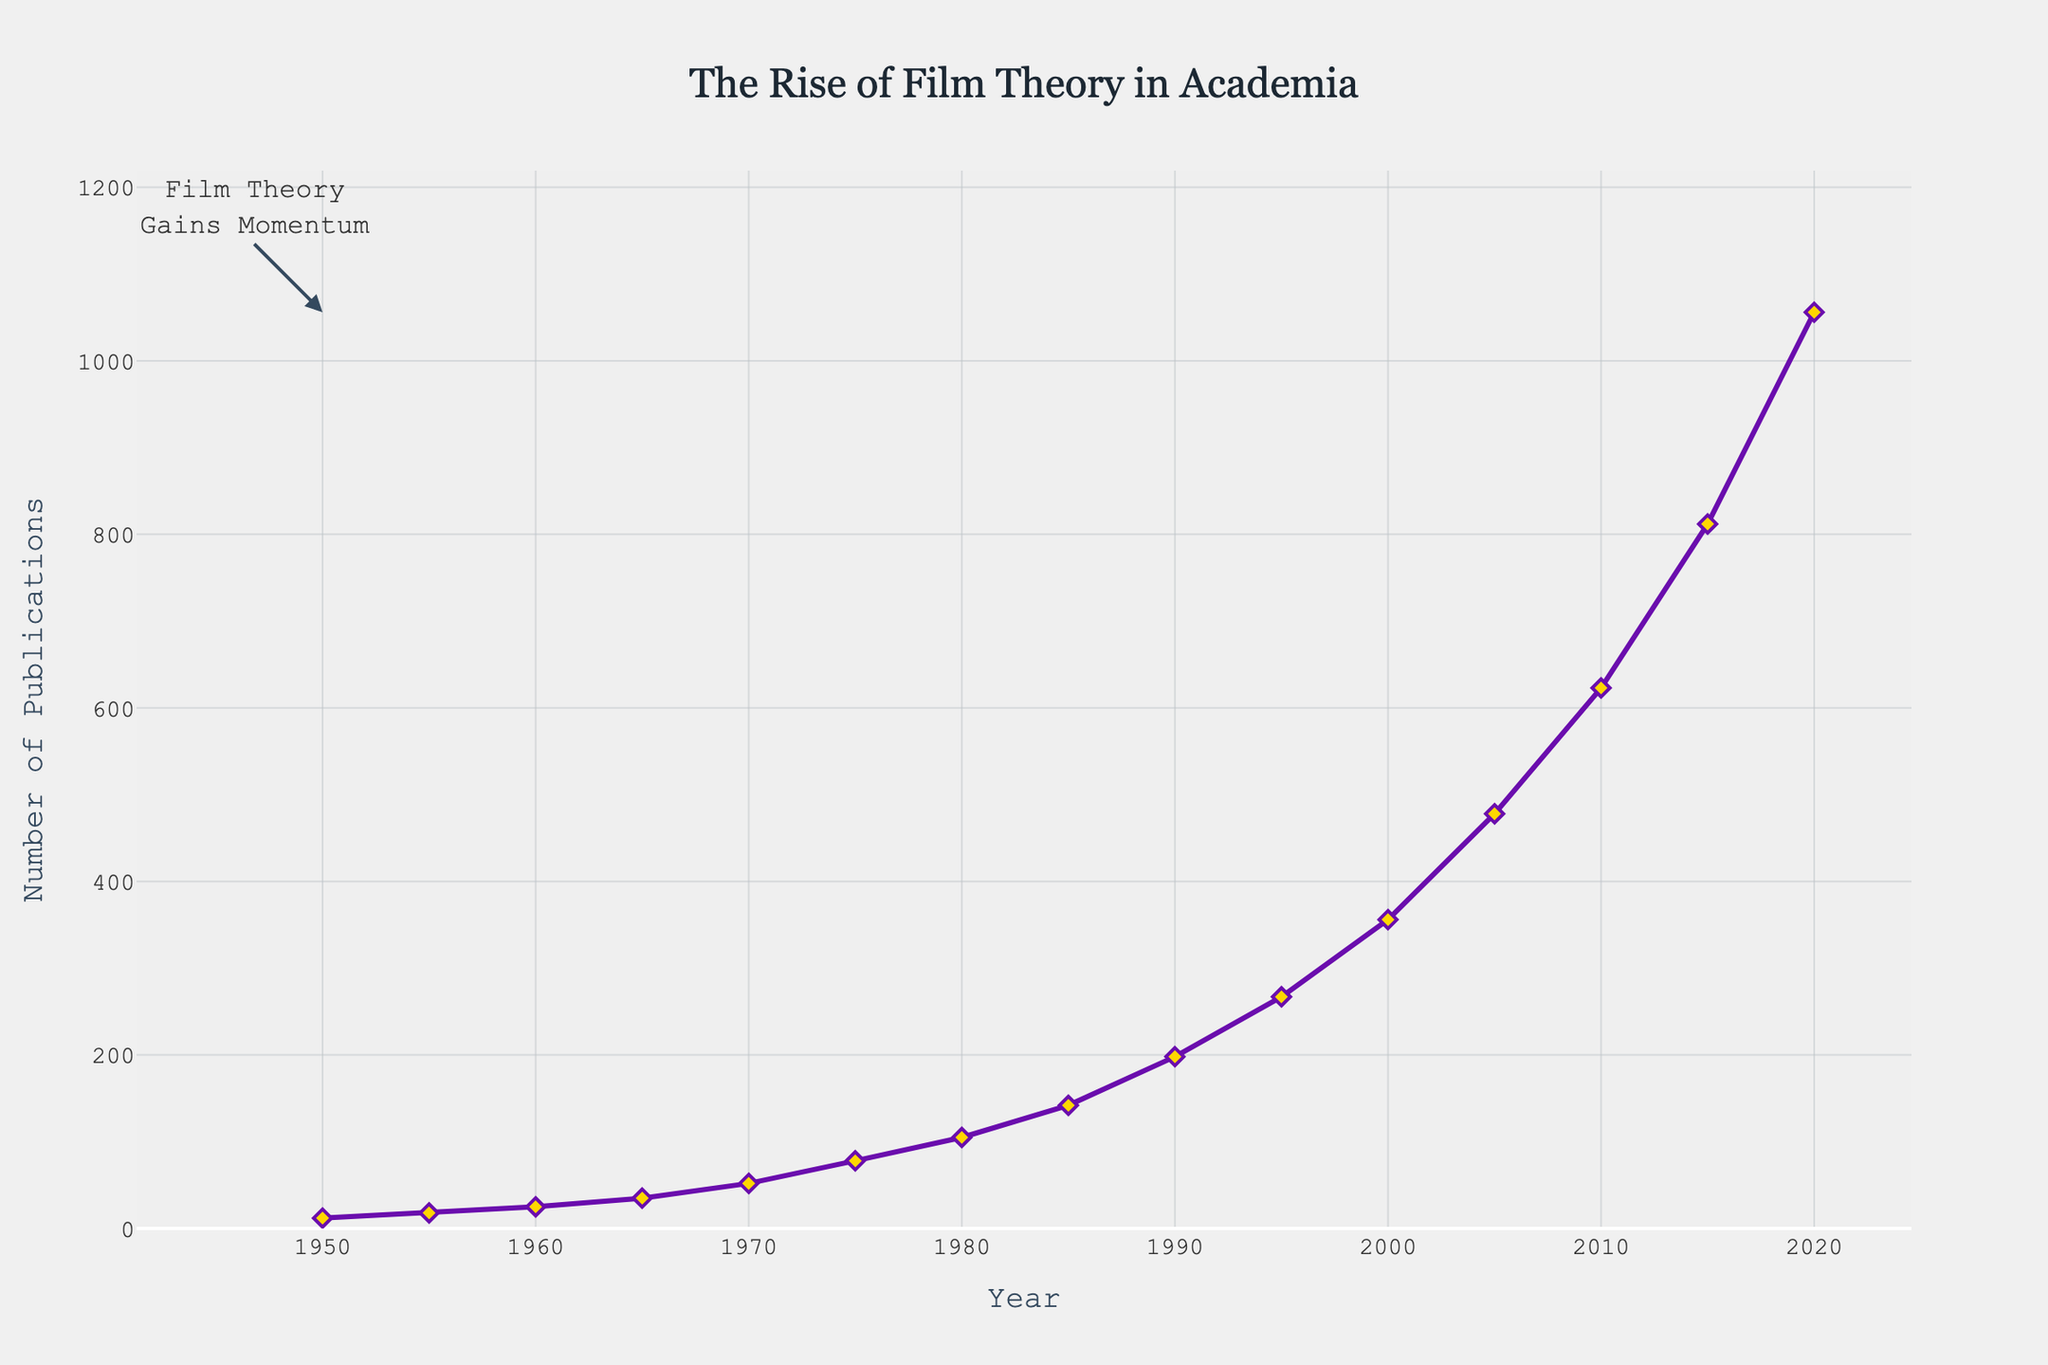What year does the number of film theory publications first exceed 100? According to the line chart, the number of publications exceeds 100 in the year 1980. This is evident from the y-axis value corresponding to the year marked on the x-axis.
Answer: 1980 Between which two consecutive years is the highest increase in the number of publications observed? To find this, we look for the steepest part of the line on the chart, indicating the largest vertical difference between two consecutive points. The steepest increase is observed between 2015 and 2020.
Answer: 2015 and 2020 In which decade does the number of film theory publications experience the most significant growth? By analyzing the slope of the line over each decade, the most significant growth is observed in the 2010s. The number of publications increases from 478 to 1056, indicating a substantial rise.
Answer: 2010s What is the approximate average number of publications per year for the period 1950 to 1975? Sum the publications for the years 1950, 1955, 1960, 1965, 1970, and 1975 and then divide by the number of data points (6). The calculation is (12+18+25+35+52+78) / 6 = 220 / 6.
Answer: Approximately 36.67 Compare the number of publications in 1960 and 2005. How many more publications were there in 2005 compared to 1960? The number of publications in 1960 is 25, and in 2005 it is 478. The difference is calculated as 478 - 25.
Answer: 453 What color are the markers representing publication data points? The markers are visually identifiable as being golden yellow.
Answer: Golden yellow What visual element highlights the period when film theory gained significant momentum? The annotation "Film Theory Gains Momentum" with an arrow points to the data point for the year 1950, explaining the noticeable upward trend.
Answer: Annotation and arrow By how much did the number of publications increase between 1980 and 1990? The number of publications in 1980 is 105, and in 1990 it is 198. The difference is calculated as 198 - 105.
Answer: 93 What is the color and style of the line representing the number of publications? The line representing the number of publications is purple and solid in style.
Answer: Purple and solid What was the overall trend in the number of film theory publications from 1950 to 2020? The overall trend in the number of publications shows a steady and significant increase from 1950 to 2020, as indicated by the upward-sloping line.
Answer: Steady increase 